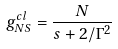Convert formula to latex. <formula><loc_0><loc_0><loc_500><loc_500>g ^ { c l } _ { N S } = \frac { N } { s + 2 / \Gamma ^ { 2 } }</formula> 